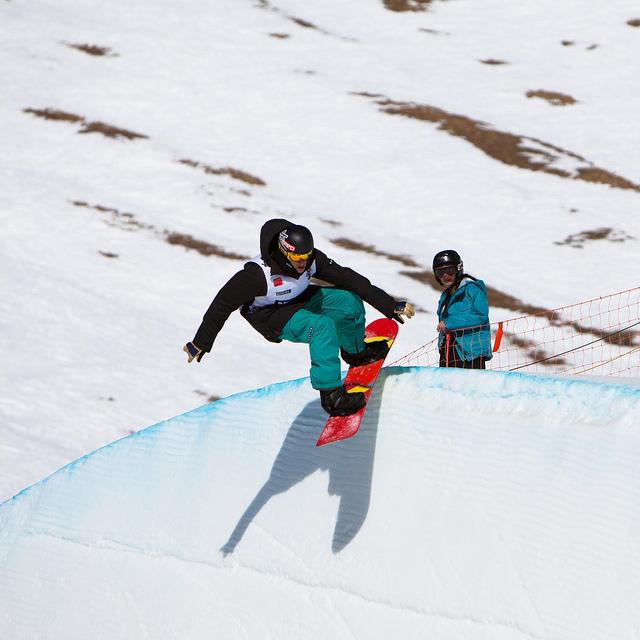What color is the front snowboard?
Answer briefly. Red. What is the shadow of?
Quick response, please. Snowboarder. Is it cold out?
Answer briefly. Yes. Is the snowboard one solid color?
Give a very brief answer. No. Do the boys have matching helmets?
Answer briefly. Yes. How many people are in the picture?
Write a very short answer. 2. What color is the snowboarder's jacket?
Quick response, please. Black. What does the snowboard say?
Answer briefly. Nothing. 